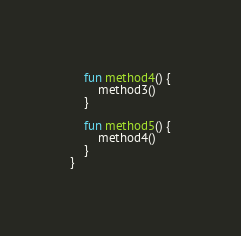<code> <loc_0><loc_0><loc_500><loc_500><_Kotlin_>    fun method4() {
        method3()
    }

    fun method5() {
        method4()
    }
}
</code> 